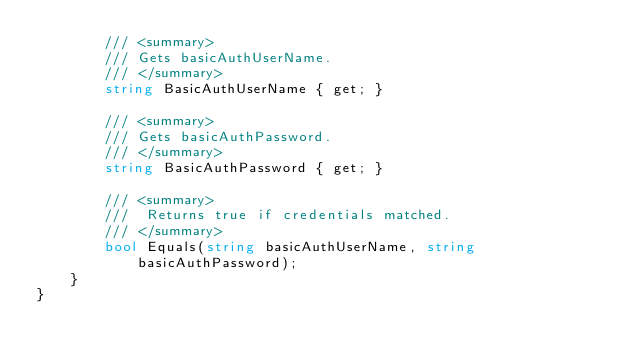Convert code to text. <code><loc_0><loc_0><loc_500><loc_500><_C#_>        /// <summary>
        /// Gets basicAuthUserName.
        /// </summary>
        string BasicAuthUserName { get; }

        /// <summary>
        /// Gets basicAuthPassword.
        /// </summary>
        string BasicAuthPassword { get; }

        /// <summary>
        ///  Returns true if credentials matched.
        /// </summary>
        bool Equals(string basicAuthUserName, string basicAuthPassword);
    }
}</code> 